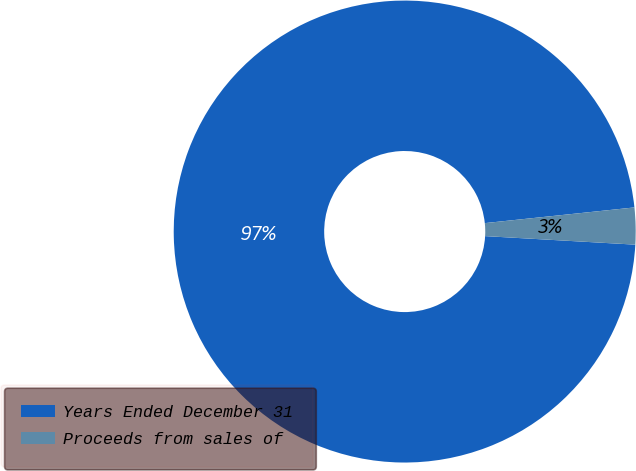Convert chart. <chart><loc_0><loc_0><loc_500><loc_500><pie_chart><fcel>Years Ended December 31<fcel>Proceeds from sales of<nl><fcel>97.43%<fcel>2.57%<nl></chart> 